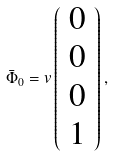Convert formula to latex. <formula><loc_0><loc_0><loc_500><loc_500>\bar { \Phi } _ { 0 } = v \left ( \begin{array} { c } 0 \\ 0 \\ 0 \\ 1 \end{array} \right ) ,</formula> 